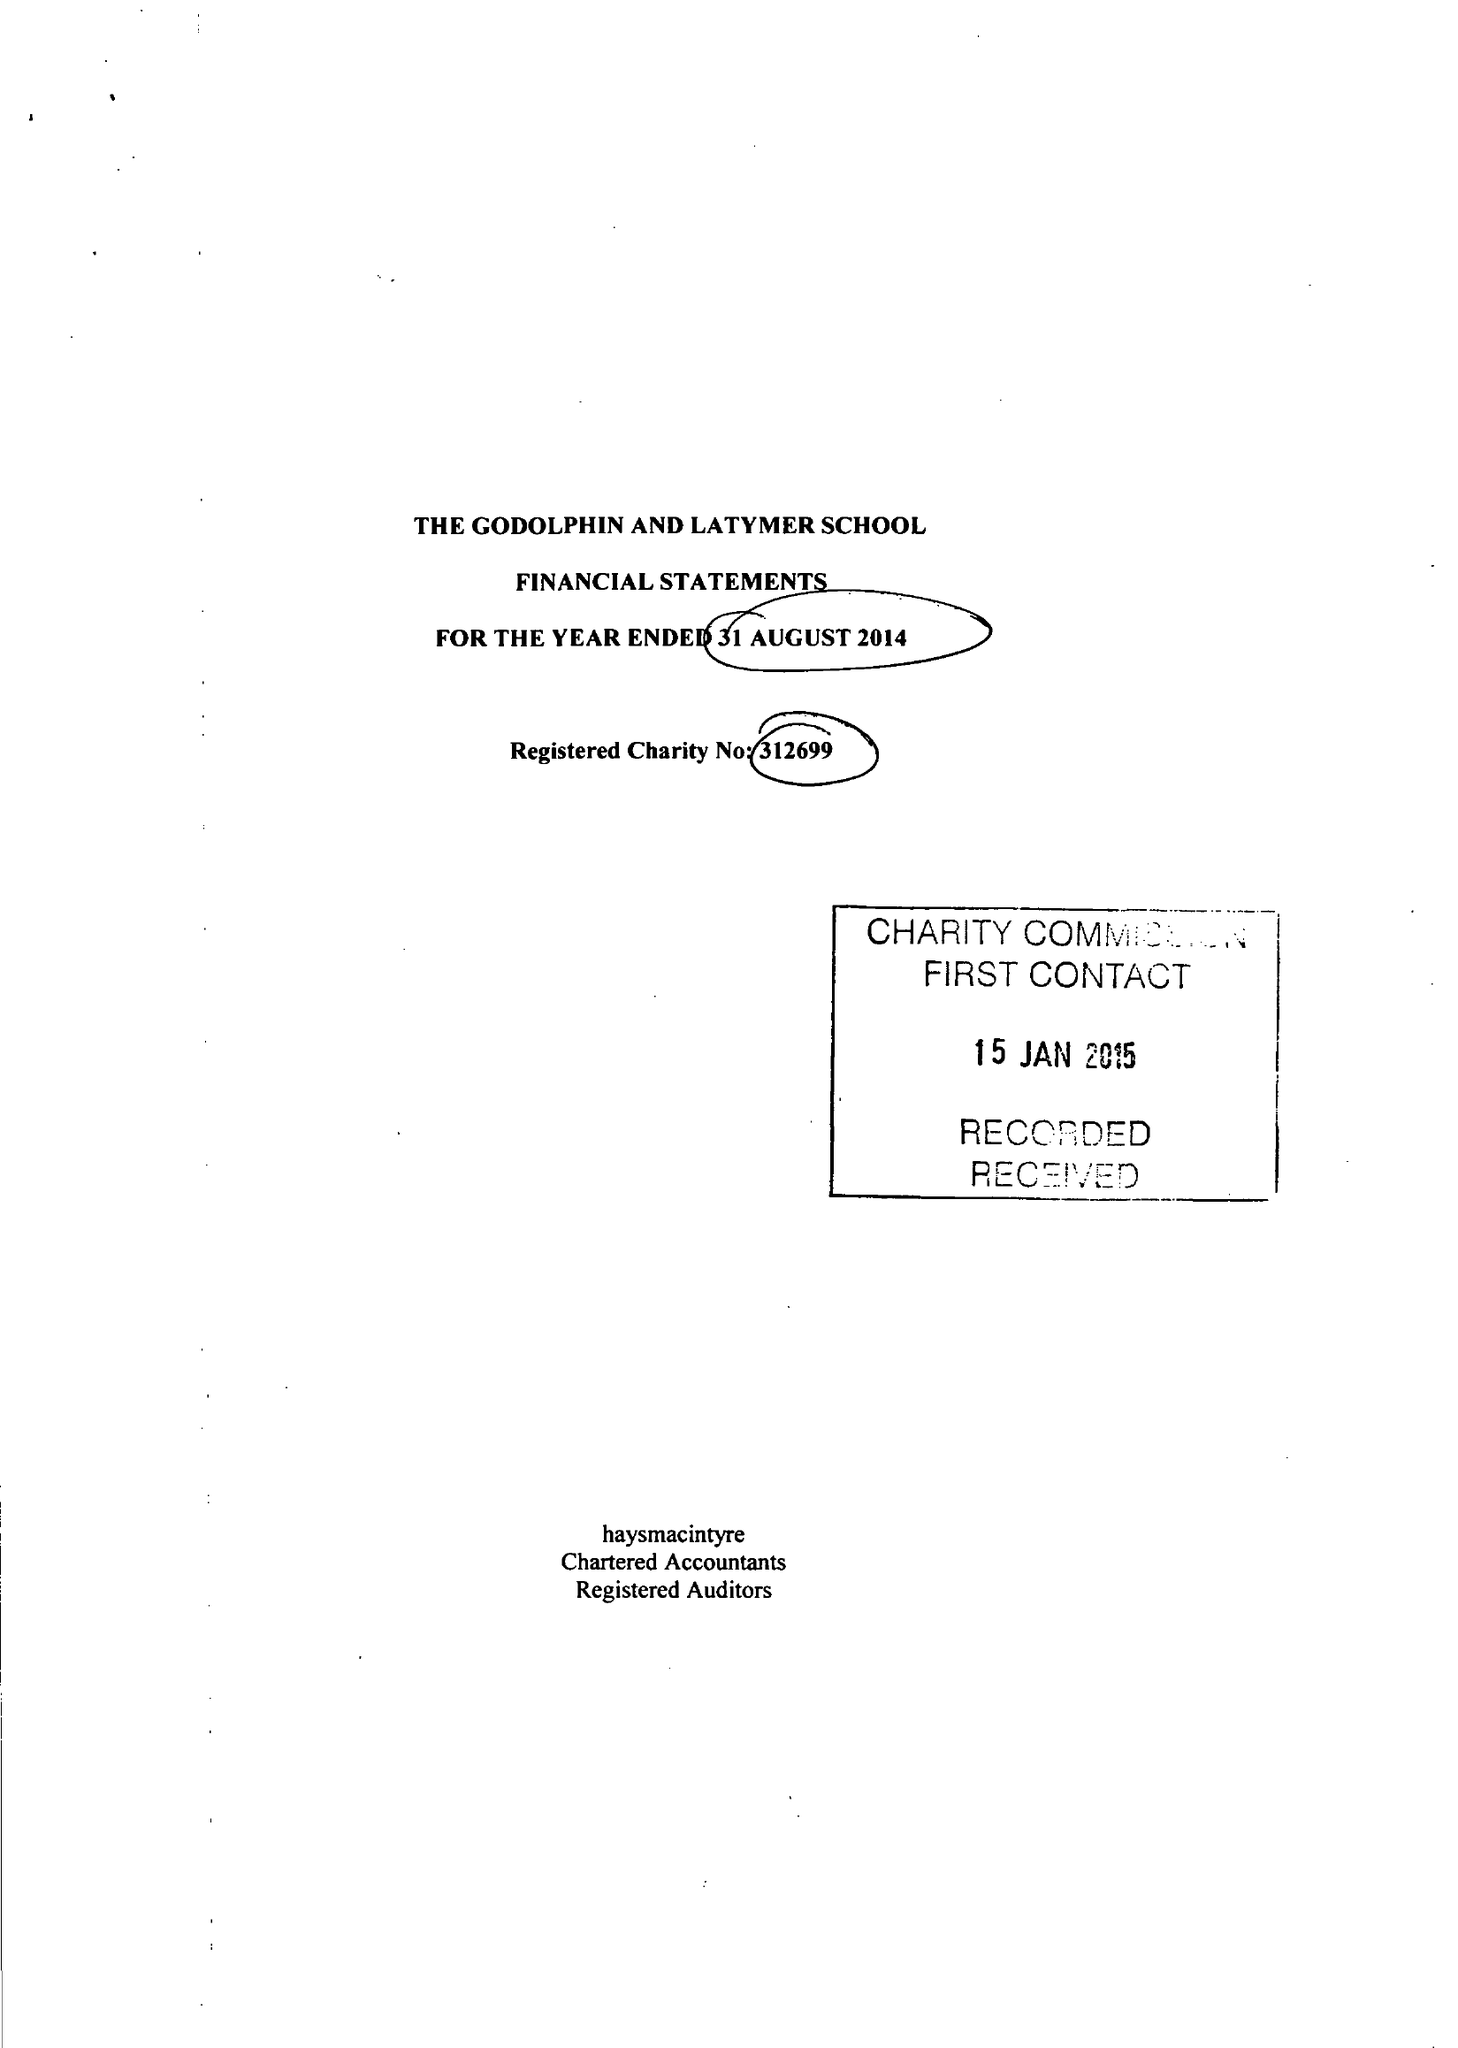What is the value for the spending_annually_in_british_pounds?
Answer the question using a single word or phrase. 13350168.00 